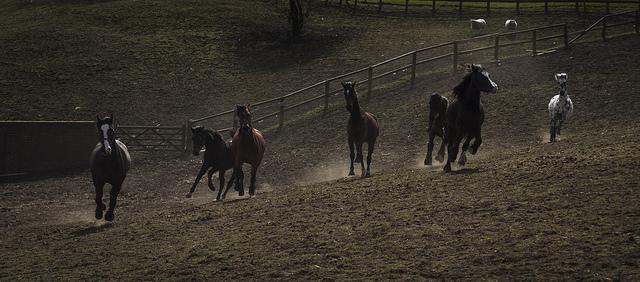How many horses are in the picture?
Give a very brief answer. 7. How many horses are running?
Give a very brief answer. 7. How many people are visible in this picture?
Give a very brief answer. 0. How many horses are there?
Give a very brief answer. 2. 